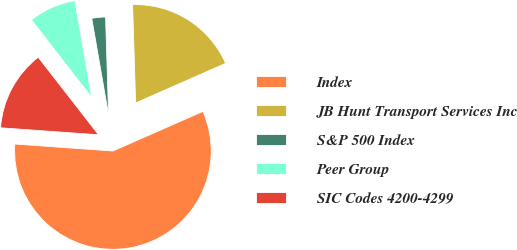Convert chart to OTSL. <chart><loc_0><loc_0><loc_500><loc_500><pie_chart><fcel>Index<fcel>JB Hunt Transport Services Inc<fcel>S&P 500 Index<fcel>Peer Group<fcel>SIC Codes 4200-4299<nl><fcel>57.73%<fcel>18.89%<fcel>2.25%<fcel>7.79%<fcel>13.34%<nl></chart> 